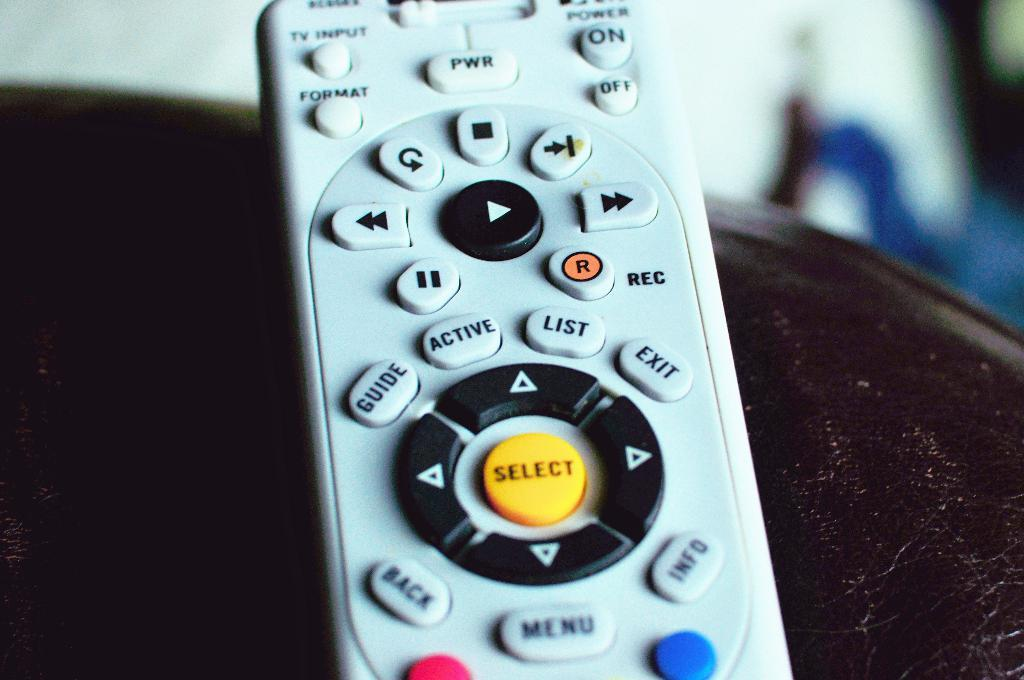<image>
Create a compact narrative representing the image presented. a close up of a remote control with a yellow button for SELECT 